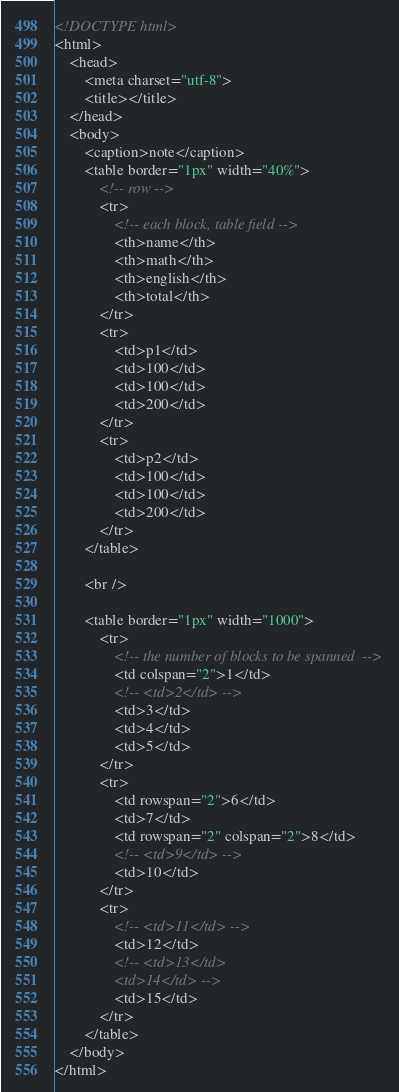<code> <loc_0><loc_0><loc_500><loc_500><_HTML_><!DOCTYPE html>
<html>
	<head>
		<meta charset="utf-8">
		<title></title>
	</head>
	<body>
		<caption>note</caption>
		<table border="1px" width="40%">
			<!-- row -->
			<tr>
				<!-- each block, table field -->
				<th>name</th>
				<th>math</th>
				<th>english</th>
				<th>total</th>
			</tr>
			<tr>
				<td>p1</td>
				<td>100</td>
				<td>100</td>
				<td>200</td>
			</tr>
			<tr>
				<td>p2</td>
				<td>100</td>
				<td>100</td>
				<td>200</td>
			</tr>
		</table>
		
		<br />
		
		<table border="1px" width="1000">
			<tr>
				<!-- the number of blocks to be spanned  -->
				<td colspan="2">1</td>
				<!-- <td>2</td> -->
				<td>3</td>
				<td>4</td>
				<td>5</td>
			</tr>
			<tr>
				<td rowspan="2">6</td>
				<td>7</td>
				<td rowspan="2" colspan="2">8</td>
				<!-- <td>9</td> -->
				<td>10</td>
			</tr>
			<tr>
				<!-- <td>11</td> -->
				<td>12</td>
				<!-- <td>13</td>
				<td>14</td> -->
				<td>15</td>
			</tr>
		</table>
	</body>
</html>
</code> 